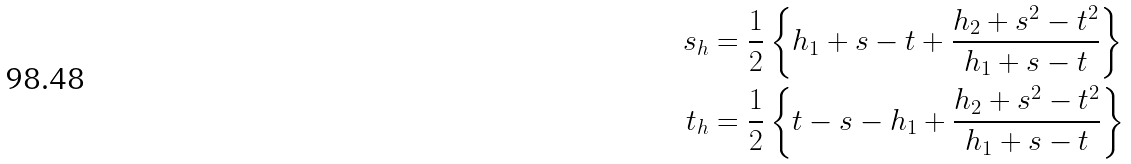Convert formula to latex. <formula><loc_0><loc_0><loc_500><loc_500>s _ { h } & = \frac { 1 } { 2 } \left \{ h _ { 1 } + s - t + \frac { h _ { 2 } + s ^ { 2 } - t ^ { 2 } } { h _ { 1 } + s - t } \right \} \\ t _ { h } & = \frac { 1 } { 2 } \left \{ t - s - h _ { 1 } + \frac { h _ { 2 } + s ^ { 2 } - t ^ { 2 } } { h _ { 1 } + s - t } \right \}</formula> 